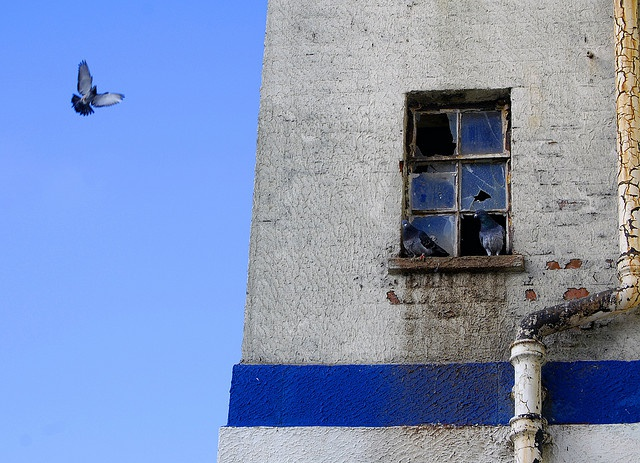Describe the objects in this image and their specific colors. I can see bird in lightblue, gray, black, navy, and darkgray tones, bird in lightblue, black, gray, and navy tones, and bird in lightblue, black, gray, and navy tones in this image. 